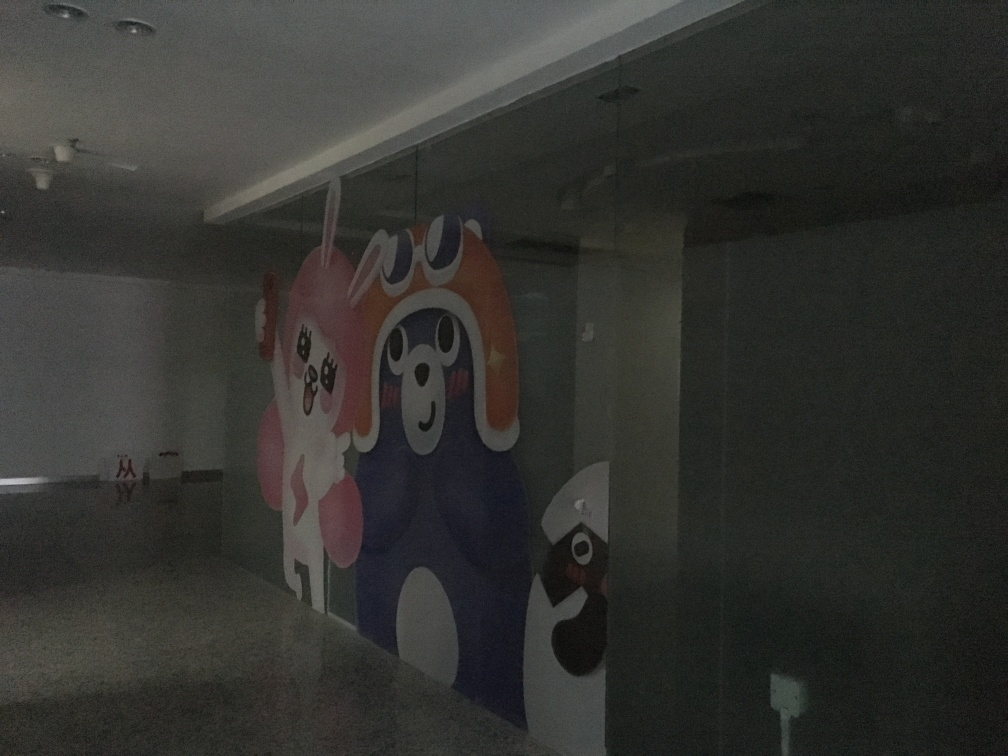How might the mood of this space change with better lighting? With improved lighting, this space would likely feel more open and welcoming. The characters in the mural would become more visible, potentially enlivening the atmosphere and making the space more interactive and enjoyable for visitors. Proper lighting can also accentuate the colors and details of the artwork, contributing to a more dynamic and engaging environment. Can you describe the colors used in the mural and their possible effect on the space? The mural utilizes a vivid palette with purples, pinks, whites, and other hues. These bright and playful colors can energize the space, elicit positive emotions, and spark creativity. If the lighting were enhanced, these colors could transform the area into a more vibrant and stimulating setting, encouraging interaction and possibly even serving as a conversation starter. 